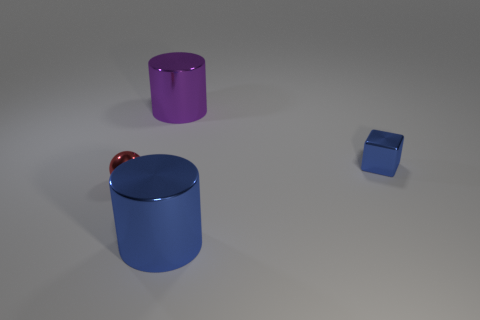Are there any other things of the same color as the small ball?
Give a very brief answer. No. What size is the purple cylinder left of the blue metallic thing to the left of the small blue object?
Provide a succinct answer. Large. What color is the metal thing that is to the right of the ball and on the left side of the big blue shiny thing?
Provide a succinct answer. Purple. What number of other things are there of the same size as the purple metal thing?
Provide a short and direct response. 1. There is a blue metal cube; does it have the same size as the cylinder that is in front of the purple cylinder?
Offer a terse response. No. What color is the cube that is the same size as the red sphere?
Provide a short and direct response. Blue. The red sphere has what size?
Your response must be concise. Small. Is the material of the cylinder that is on the left side of the big blue cylinder the same as the small red sphere?
Your response must be concise. Yes. Is the small red metal object the same shape as the big blue object?
Give a very brief answer. No. There is a red thing to the left of the shiny cylinder to the right of the big metallic cylinder that is behind the red metallic ball; what shape is it?
Your response must be concise. Sphere. 